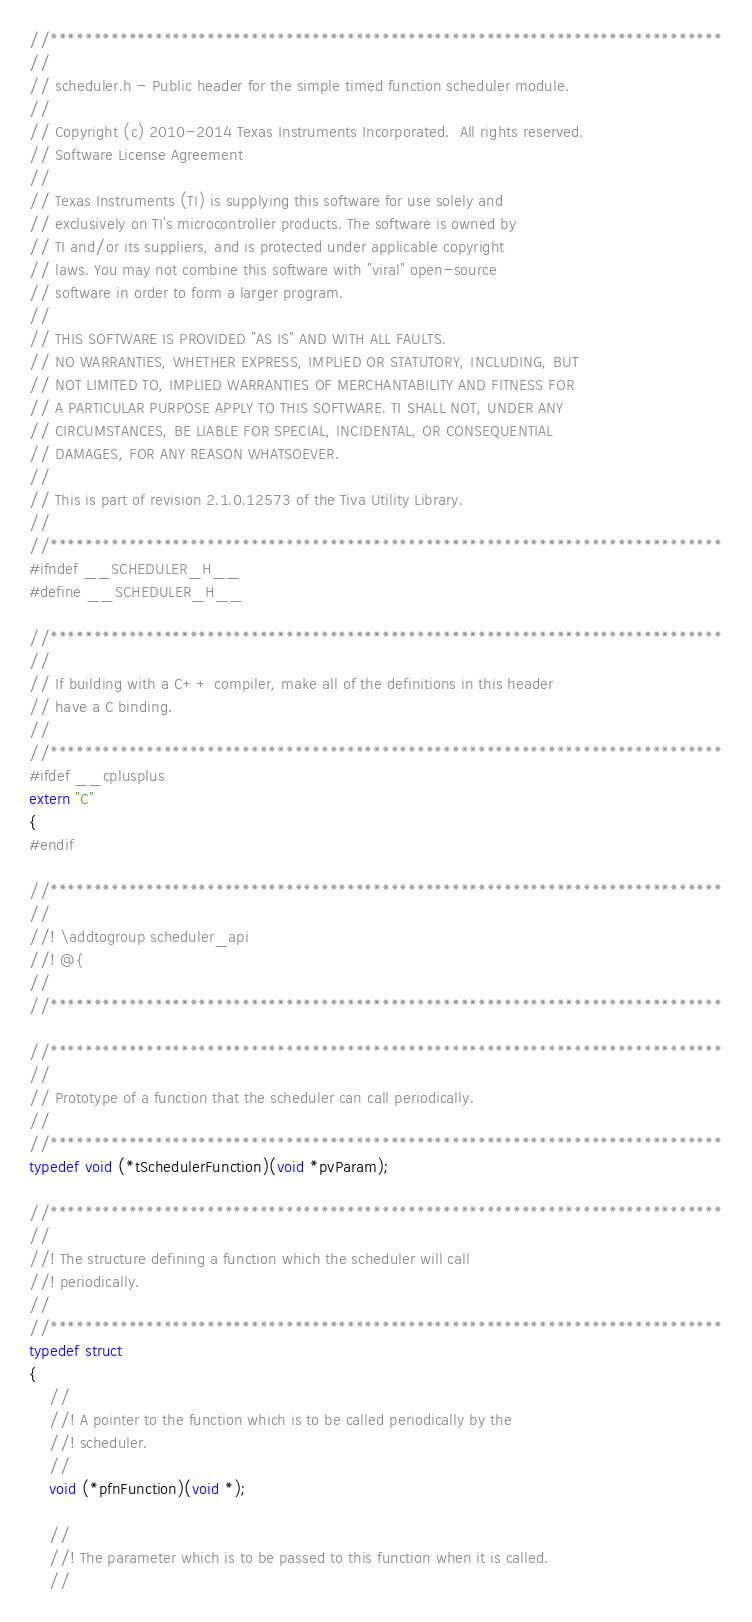Convert code to text. <code><loc_0><loc_0><loc_500><loc_500><_C_>//*****************************************************************************
//
// scheduler.h - Public header for the simple timed function scheduler module.
//
// Copyright (c) 2010-2014 Texas Instruments Incorporated.  All rights reserved.
// Software License Agreement
// 
// Texas Instruments (TI) is supplying this software for use solely and
// exclusively on TI's microcontroller products. The software is owned by
// TI and/or its suppliers, and is protected under applicable copyright
// laws. You may not combine this software with "viral" open-source
// software in order to form a larger program.
// 
// THIS SOFTWARE IS PROVIDED "AS IS" AND WITH ALL FAULTS.
// NO WARRANTIES, WHETHER EXPRESS, IMPLIED OR STATUTORY, INCLUDING, BUT
// NOT LIMITED TO, IMPLIED WARRANTIES OF MERCHANTABILITY AND FITNESS FOR
// A PARTICULAR PURPOSE APPLY TO THIS SOFTWARE. TI SHALL NOT, UNDER ANY
// CIRCUMSTANCES, BE LIABLE FOR SPECIAL, INCIDENTAL, OR CONSEQUENTIAL
// DAMAGES, FOR ANY REASON WHATSOEVER.
// 
// This is part of revision 2.1.0.12573 of the Tiva Utility Library.
//
//*****************************************************************************
#ifndef __SCHEDULER_H__
#define __SCHEDULER_H__

//*****************************************************************************
//
// If building with a C++ compiler, make all of the definitions in this header
// have a C binding.
//
//*****************************************************************************
#ifdef __cplusplus
extern "C"
{
#endif

//*****************************************************************************
//
//! \addtogroup scheduler_api
//! @{
//
//*****************************************************************************

//*****************************************************************************
//
// Prototype of a function that the scheduler can call periodically.
//
//*****************************************************************************
typedef void (*tSchedulerFunction)(void *pvParam);

//*****************************************************************************
//
//! The structure defining a function which the scheduler will call
//! periodically.
//
//*****************************************************************************
typedef struct
{
    //
    //! A pointer to the function which is to be called periodically by the
    //! scheduler.
    //
    void (*pfnFunction)(void *);

    //
    //! The parameter which is to be passed to this function when it is called.
    //</code> 